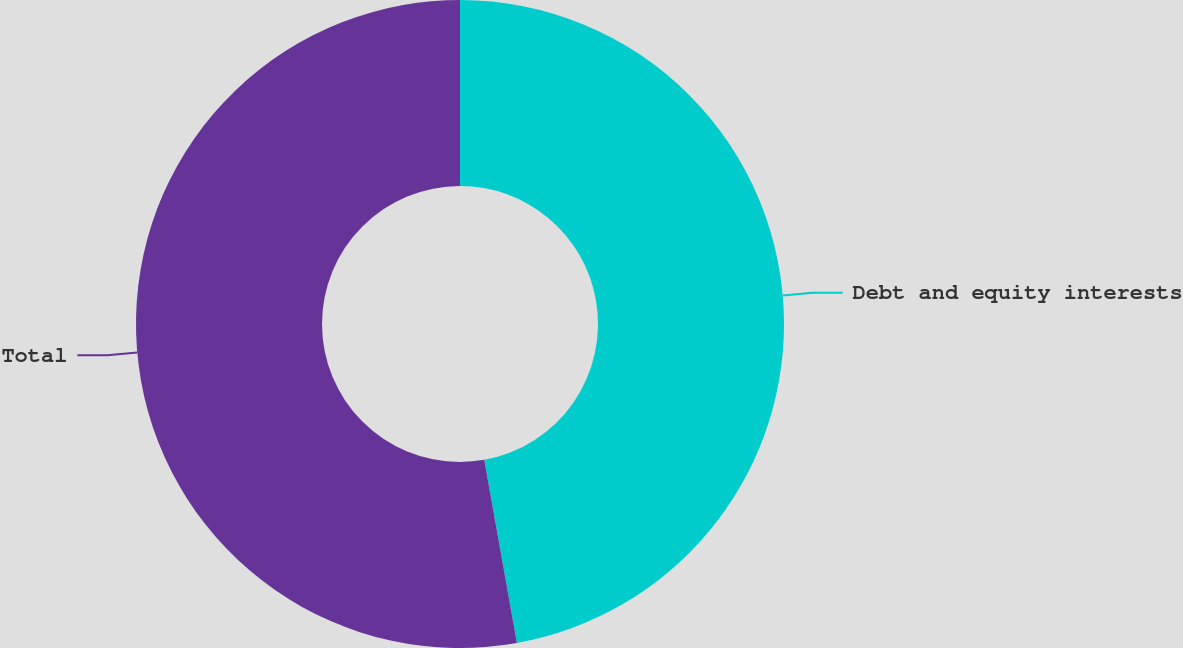<chart> <loc_0><loc_0><loc_500><loc_500><pie_chart><fcel>Debt and equity interests<fcel>Total<nl><fcel>47.19%<fcel>52.81%<nl></chart> 